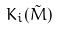Convert formula to latex. <formula><loc_0><loc_0><loc_500><loc_500>K _ { i } ( \tilde { M } )</formula> 